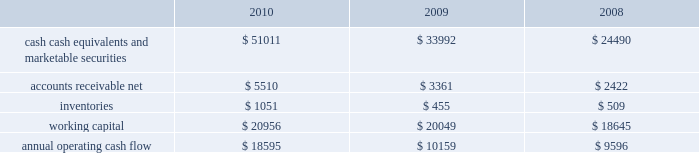Table of contents primarily to certain undistributed foreign earnings for which no u.s .
Taxes are provided because such earnings are intended to be indefinitely reinvested outside the u.s .
The lower effective tax rate in 2010 as compared to 2009 is due primarily to an increase in foreign earnings on which u.s .
Income taxes have not been provided as such earnings are intended to be indefinitely reinvested outside the u.s .
As of september 25 , 2010 , the company had deferred tax assets arising from deductible temporary differences , tax losses , and tax credits of $ 2.4 billion , and deferred tax liabilities of $ 5.0 billion .
Management believes it is more likely than not that forecasted income , including income that may be generated as a result of certain tax planning strategies , together with future reversals of existing taxable temporary differences , will be sufficient to fully recover the deferred tax assets .
The company will continue to evaluate the realizability of deferred tax assets quarterly by assessing the need for and amount of a valuation allowance .
The internal revenue service ( the 201cirs 201d ) has completed its field audit of the company 2019s federal income tax returns for the years 2004 through 2006 and proposed certain adjustments .
The company has contested certain of these adjustments through the irs appeals office .
The irs is currently examining the years 2007 through 2009 .
All irs audit issues for years prior to 2004 have been resolved .
During the third quarter of 2010 , the company reached a tax settlement with the irs for the years 2002 through 2003 .
In addition , the company is subject to audits by state , local , and foreign tax authorities .
Management believes that adequate provision has been made for any adjustments that may result from tax examinations .
However , the outcome of tax audits cannot be predicted with certainty .
If any issues addressed in the company 2019s tax audits are resolved in a manner not consistent with management 2019s expectations , the company could be required to adjust its provision for income taxes in the period such resolution occurs .
Liquidity and capital resources the table presents selected financial information and statistics as of and for the three years ended september 25 , 2010 ( in millions ) : as of september 25 , 2010 , the company had $ 51 billion in cash , cash equivalents and marketable securities , an increase of $ 17 billion from september 26 , 2009 .
The principal component of this net increase was the cash generated by operating activities of $ 18.6 billion , which was partially offset by payments for acquisition of property , plant and equipment of $ 2 billion and payments made in connection with business acquisitions , net of cash acquired , of $ 638 million .
The company 2019s marketable securities investment portfolio is invested primarily in highly rated securities , generally with a minimum rating of single-a or equivalent .
As of september 25 , 2010 and september 26 , 2009 , $ 30.8 billion and $ 17.4 billion , respectively , of the company 2019s cash , cash equivalents and marketable securities were held by foreign subsidiaries and are generally based in u.s .
Dollar-denominated holdings .
The company believes its existing balances of cash , cash equivalents and marketable securities will be sufficient to satisfy its working capital needs , capital asset purchases , outstanding commitments and other liquidity requirements associated with its existing operations over the next 12 months. .

What was the lowest amount of inventories , in millions? 
Computations: table_min(inventories, none)
Answer: 455.0. 